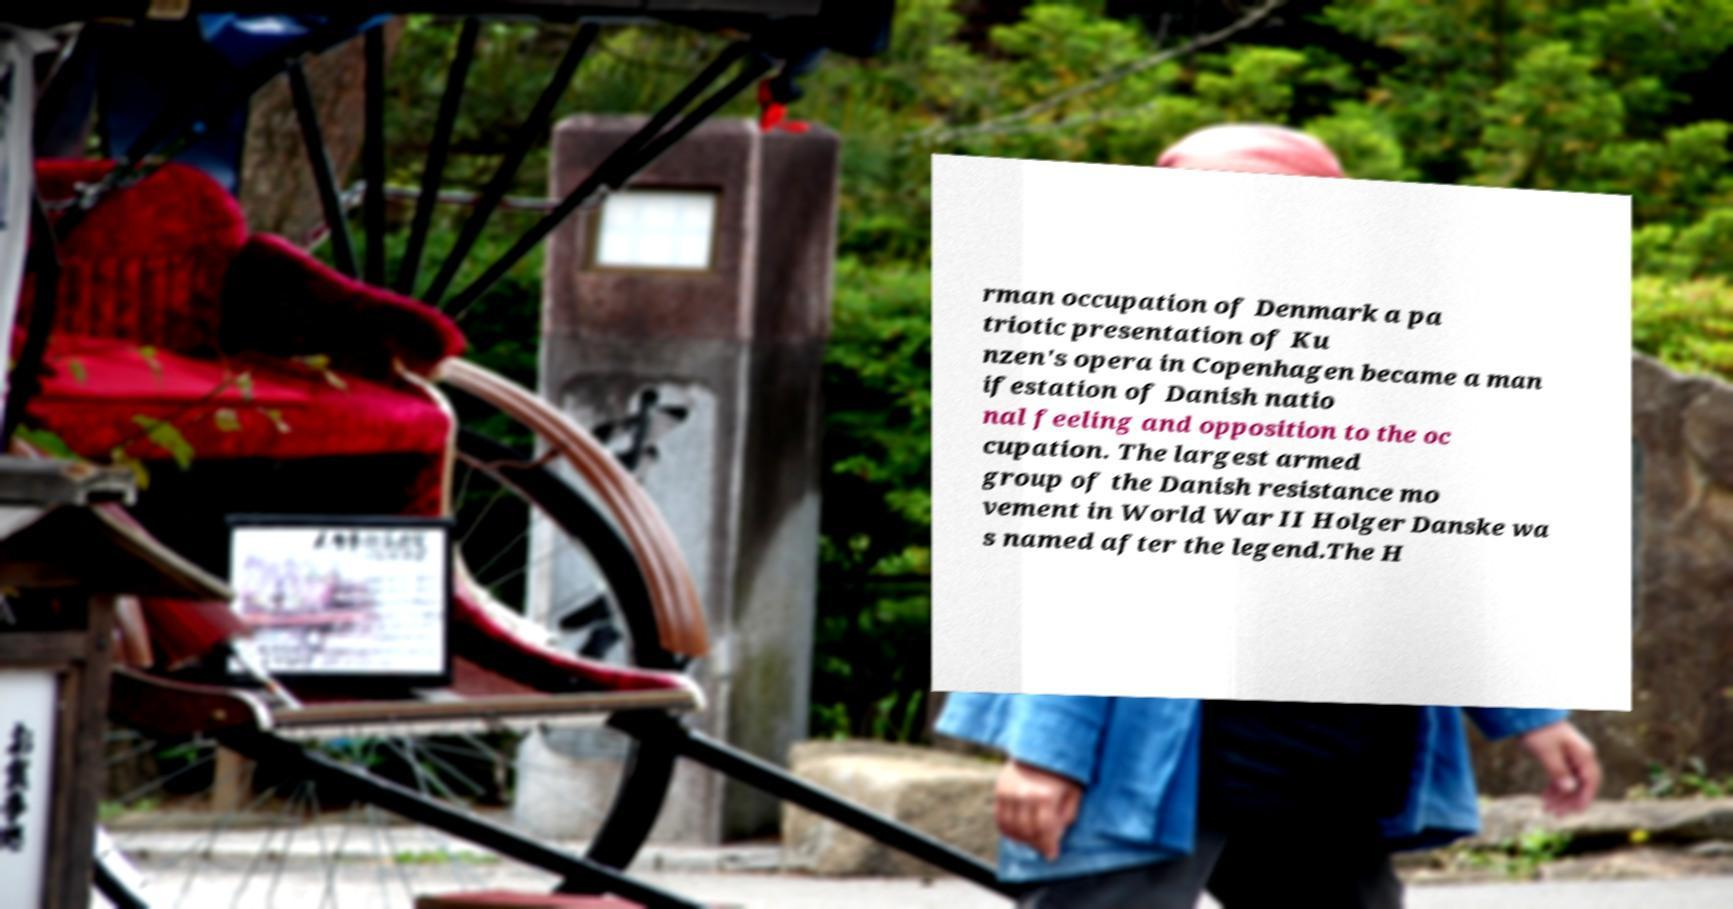Can you read and provide the text displayed in the image?This photo seems to have some interesting text. Can you extract and type it out for me? rman occupation of Denmark a pa triotic presentation of Ku nzen's opera in Copenhagen became a man ifestation of Danish natio nal feeling and opposition to the oc cupation. The largest armed group of the Danish resistance mo vement in World War II Holger Danske wa s named after the legend.The H 